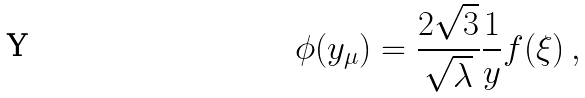Convert formula to latex. <formula><loc_0><loc_0><loc_500><loc_500>\phi ( y _ { \mu } ) = \frac { 2 \sqrt { 3 } } { \sqrt { \lambda } } \frac { 1 } { y } f ( \xi ) \, ,</formula> 